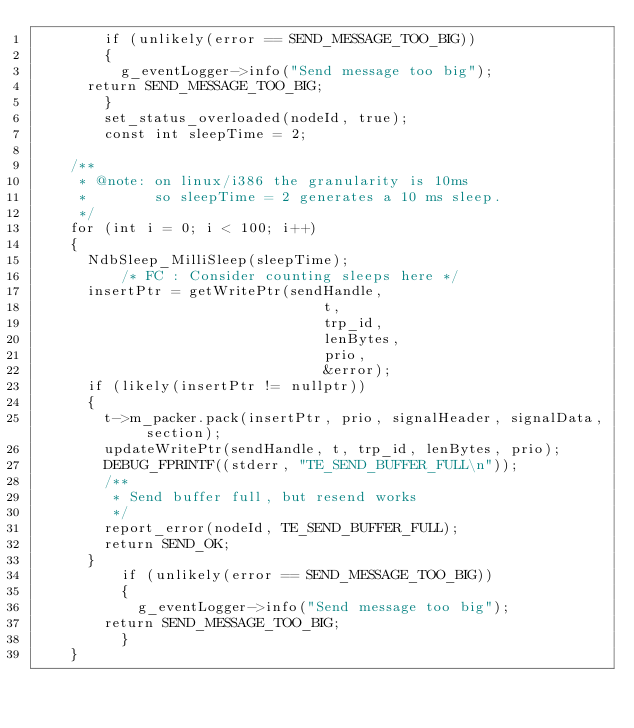<code> <loc_0><loc_0><loc_500><loc_500><_C++_>        if (unlikely(error == SEND_MESSAGE_TOO_BIG))
        {
          g_eventLogger->info("Send message too big");
	  return SEND_MESSAGE_TOO_BIG;
        }
        set_status_overloaded(nodeId, true);
        const int sleepTime = 2;

	/**
	 * @note: on linux/i386 the granularity is 10ms
	 *        so sleepTime = 2 generates a 10 ms sleep.
	 */
	for (int i = 0; i < 100; i++)
	{
	  NdbSleep_MilliSleep(sleepTime);
          /* FC : Consider counting sleeps here */
	  insertPtr = getWritePtr(sendHandle,
                                  t,
                                  trp_id,
                                  lenBytes,
                                  prio,
                                  &error);
	  if (likely(insertPtr != nullptr))
	  {
	    t->m_packer.pack(insertPtr, prio, signalHeader, signalData, section);
	    updateWritePtr(sendHandle, t, trp_id, lenBytes, prio);
	    DEBUG_FPRINTF((stderr, "TE_SEND_BUFFER_FULL\n"));
	    /**
	     * Send buffer full, but resend works
	     */
	    report_error(nodeId, TE_SEND_BUFFER_FULL);
	    return SEND_OK;
	  }
          if (unlikely(error == SEND_MESSAGE_TOO_BIG))
          {
            g_eventLogger->info("Send message too big");
	    return SEND_MESSAGE_TOO_BIG;
          }
	}
</code> 